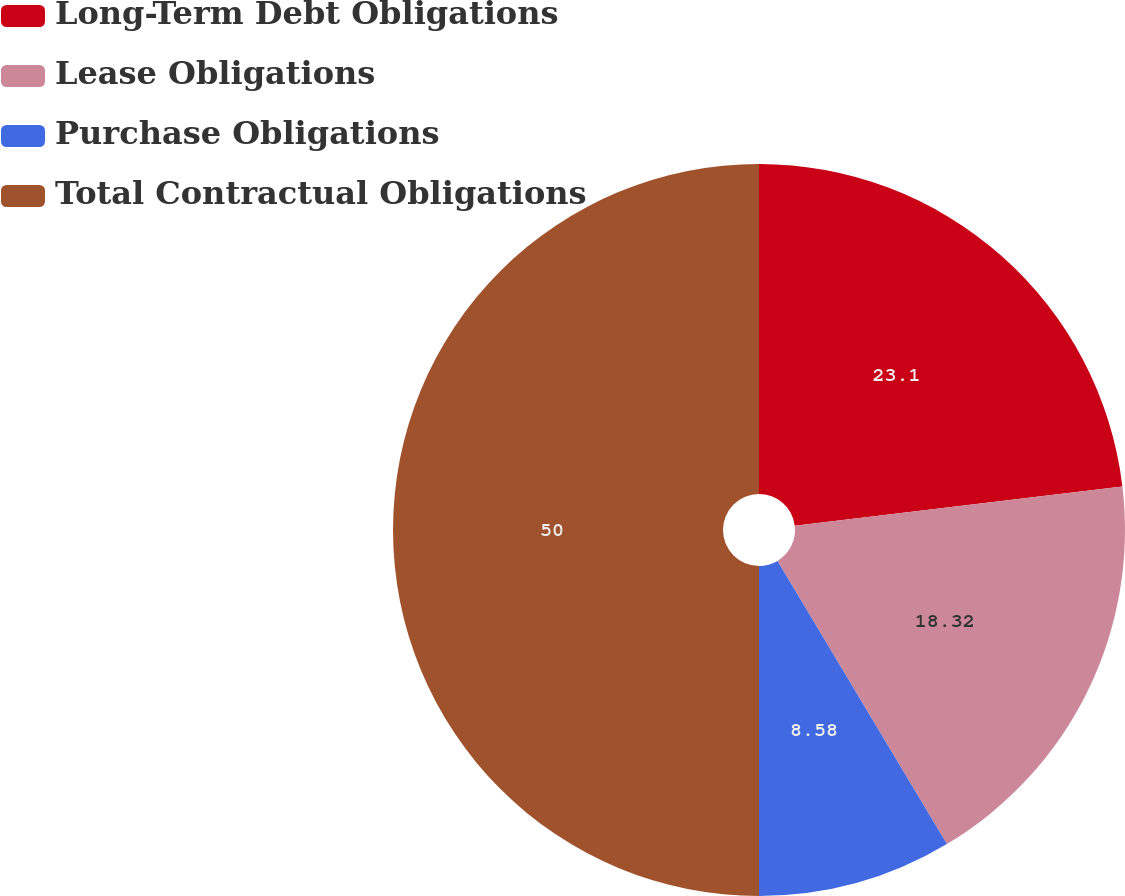<chart> <loc_0><loc_0><loc_500><loc_500><pie_chart><fcel>Long-Term Debt Obligations<fcel>Lease Obligations<fcel>Purchase Obligations<fcel>Total Contractual Obligations<nl><fcel>23.1%<fcel>18.32%<fcel>8.58%<fcel>50.0%<nl></chart> 